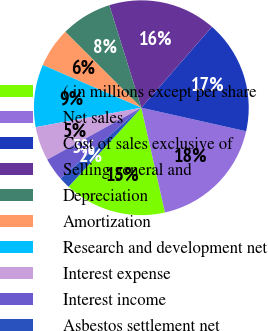Convert chart. <chart><loc_0><loc_0><loc_500><loc_500><pie_chart><fcel>( in millions except per share<fcel>Net sales<fcel>Cost of sales exclusive of<fcel>Selling general and<fcel>Depreciation<fcel>Amortization<fcel>Research and development net<fcel>Interest expense<fcel>Interest income<fcel>Asbestos settlement net<nl><fcel>15.38%<fcel>17.95%<fcel>17.09%<fcel>16.24%<fcel>7.69%<fcel>5.98%<fcel>9.4%<fcel>5.13%<fcel>3.42%<fcel>1.71%<nl></chart> 